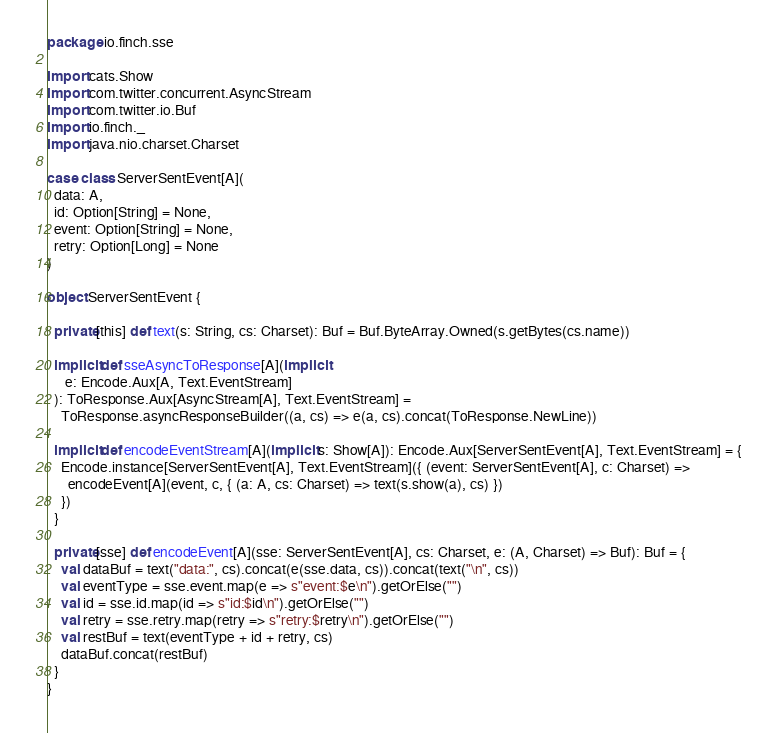<code> <loc_0><loc_0><loc_500><loc_500><_Scala_>package io.finch.sse

import cats.Show
import com.twitter.concurrent.AsyncStream
import com.twitter.io.Buf
import io.finch._
import java.nio.charset.Charset

case class ServerSentEvent[A](
  data: A,
  id: Option[String] = None,
  event: Option[String] = None,
  retry: Option[Long] = None
)

object ServerSentEvent {

  private[this] def text(s: String, cs: Charset): Buf = Buf.ByteArray.Owned(s.getBytes(cs.name))

  implicit def sseAsyncToResponse[A](implicit
     e: Encode.Aux[A, Text.EventStream]
  ): ToResponse.Aux[AsyncStream[A], Text.EventStream] =
    ToResponse.asyncResponseBuilder((a, cs) => e(a, cs).concat(ToResponse.NewLine))

  implicit def encodeEventStream[A](implicit s: Show[A]): Encode.Aux[ServerSentEvent[A], Text.EventStream] = {
    Encode.instance[ServerSentEvent[A], Text.EventStream]({ (event: ServerSentEvent[A], c: Charset) =>
      encodeEvent[A](event, c, { (a: A, cs: Charset) => text(s.show(a), cs) })
    })
  }

  private[sse] def encodeEvent[A](sse: ServerSentEvent[A], cs: Charset, e: (A, Charset) => Buf): Buf = {
    val dataBuf = text("data:", cs).concat(e(sse.data, cs)).concat(text("\n", cs))
    val eventType = sse.event.map(e => s"event:$e\n").getOrElse("")
    val id = sse.id.map(id => s"id:$id\n").getOrElse("")
    val retry = sse.retry.map(retry => s"retry:$retry\n").getOrElse("")
    val restBuf = text(eventType + id + retry, cs)
    dataBuf.concat(restBuf)
  }
}
</code> 